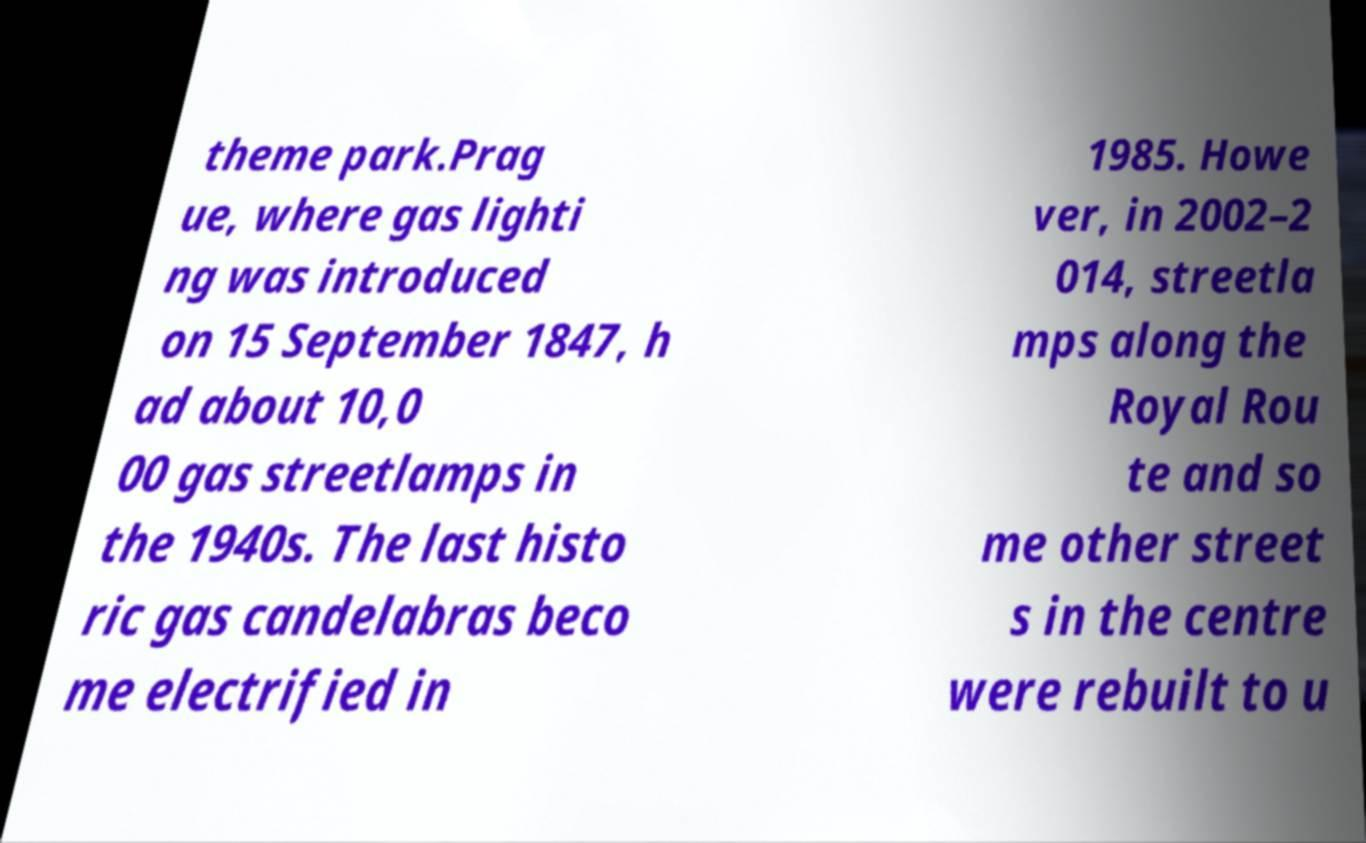Can you accurately transcribe the text from the provided image for me? theme park.Prag ue, where gas lighti ng was introduced on 15 September 1847, h ad about 10,0 00 gas streetlamps in the 1940s. The last histo ric gas candelabras beco me electrified in 1985. Howe ver, in 2002–2 014, streetla mps along the Royal Rou te and so me other street s in the centre were rebuilt to u 